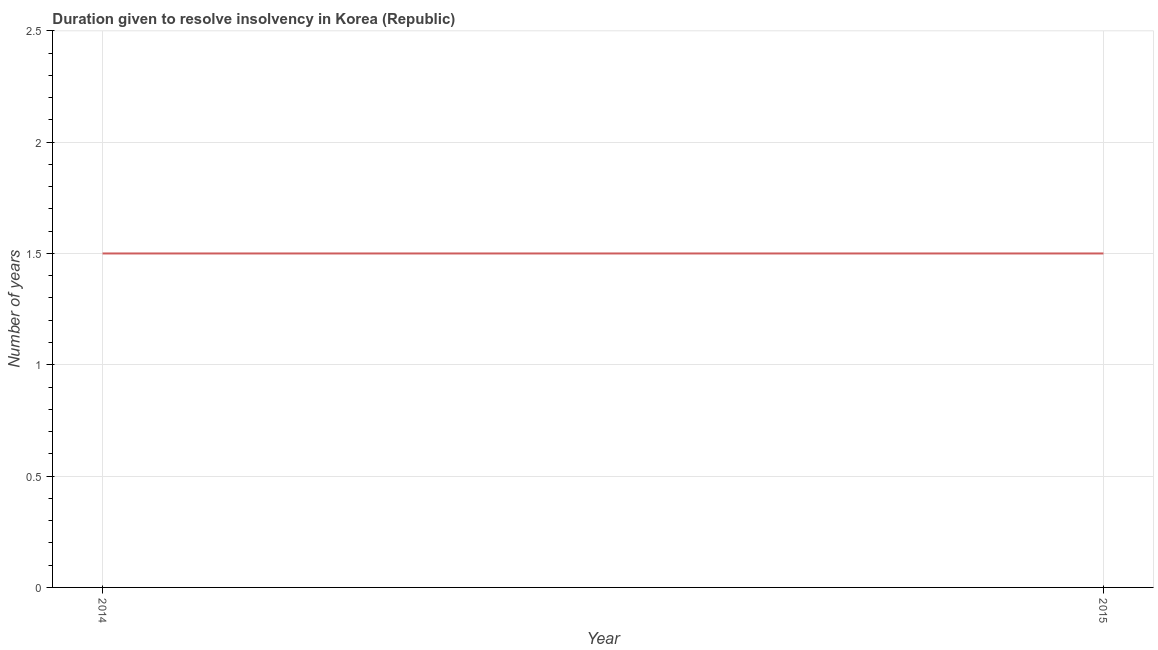Across all years, what is the maximum number of years to resolve insolvency?
Offer a terse response. 1.5. In which year was the number of years to resolve insolvency maximum?
Your response must be concise. 2014. In which year was the number of years to resolve insolvency minimum?
Give a very brief answer. 2014. What is the average number of years to resolve insolvency per year?
Keep it short and to the point. 1.5. What is the median number of years to resolve insolvency?
Your answer should be very brief. 1.5. Do a majority of the years between 2015 and 2014 (inclusive) have number of years to resolve insolvency greater than 1.9 ?
Provide a short and direct response. No. In how many years, is the number of years to resolve insolvency greater than the average number of years to resolve insolvency taken over all years?
Provide a short and direct response. 0. Does the number of years to resolve insolvency monotonically increase over the years?
Give a very brief answer. No. How many years are there in the graph?
Keep it short and to the point. 2. What is the difference between two consecutive major ticks on the Y-axis?
Your response must be concise. 0.5. Does the graph contain any zero values?
Your answer should be very brief. No. What is the title of the graph?
Ensure brevity in your answer.  Duration given to resolve insolvency in Korea (Republic). What is the label or title of the Y-axis?
Your answer should be very brief. Number of years. What is the Number of years in 2015?
Your response must be concise. 1.5. What is the ratio of the Number of years in 2014 to that in 2015?
Ensure brevity in your answer.  1. 